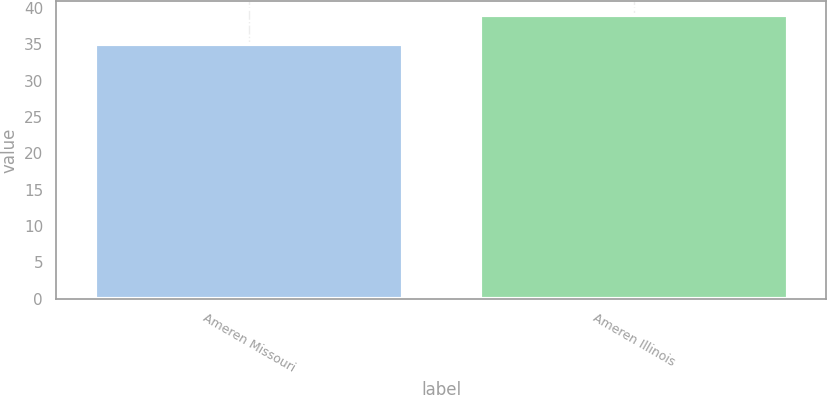Convert chart to OTSL. <chart><loc_0><loc_0><loc_500><loc_500><bar_chart><fcel>Ameren Missouri<fcel>Ameren Illinois<nl><fcel>35<fcel>39<nl></chart> 